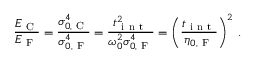<formula> <loc_0><loc_0><loc_500><loc_500>\frac { E _ { C } } { E _ { F } } = \frac { \sigma _ { 0 , C } ^ { 4 } } { \sigma _ { 0 , F } ^ { 4 } } = \frac { t _ { i n t } ^ { 2 } } { \omega _ { 0 } ^ { 2 } \sigma _ { 0 , F } ^ { 4 } } = \left ( \frac { t _ { i n t } } { \eta _ { 0 , F } } \right ) ^ { 2 } \, .</formula> 